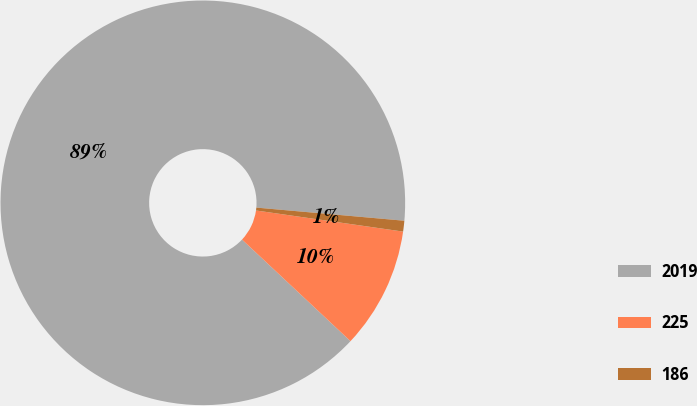Convert chart to OTSL. <chart><loc_0><loc_0><loc_500><loc_500><pie_chart><fcel>2019<fcel>225<fcel>186<nl><fcel>89.43%<fcel>9.71%<fcel>0.86%<nl></chart> 